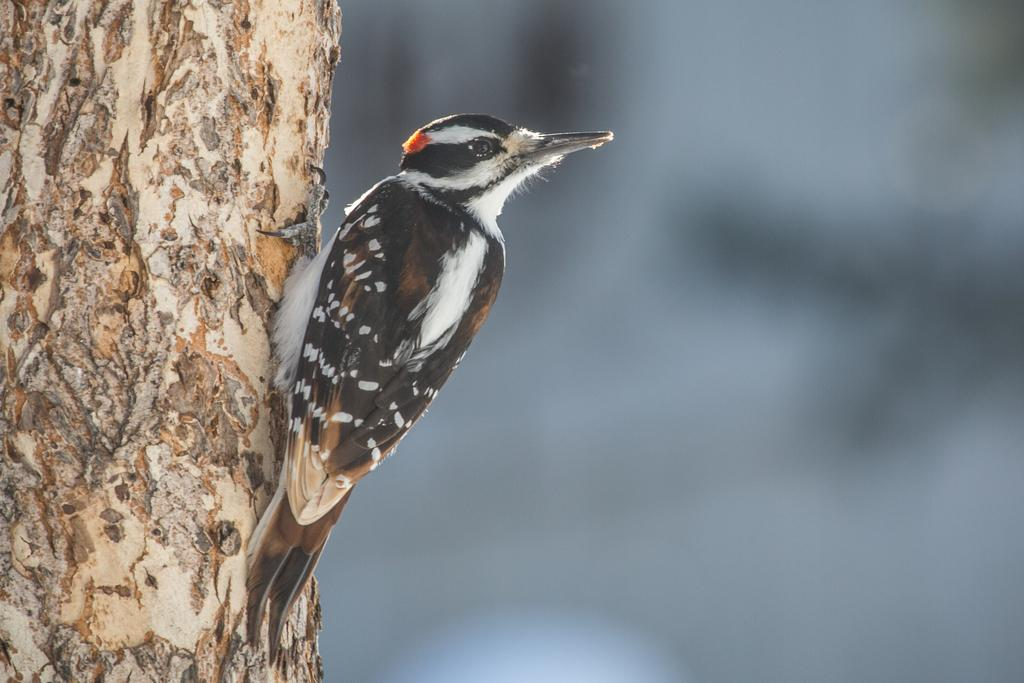What type of animal can be seen in the picture? There is a bird in the picture. How is the bird positioned in the image? The bird is standing by holding the tree trunk. Can you describe the background of the image? The background of the image is blurry. What type of fight is taking place in the image? There is no fight present in the image; it features a bird standing by holding the tree trunk. Where is the hall located in the image? There is no hall present in the image. 